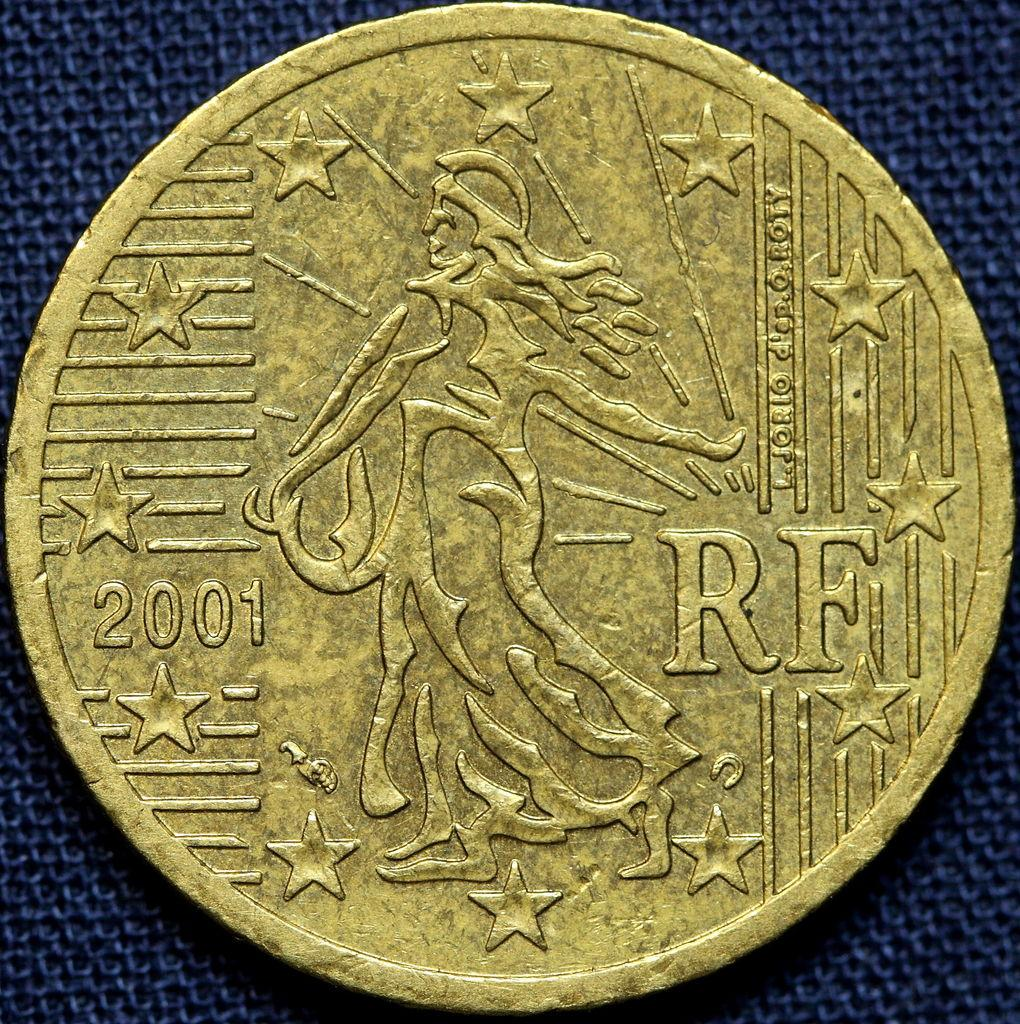<image>
Describe the image concisely. A RF gold coin from 2001 with stars all around the perimeter. 